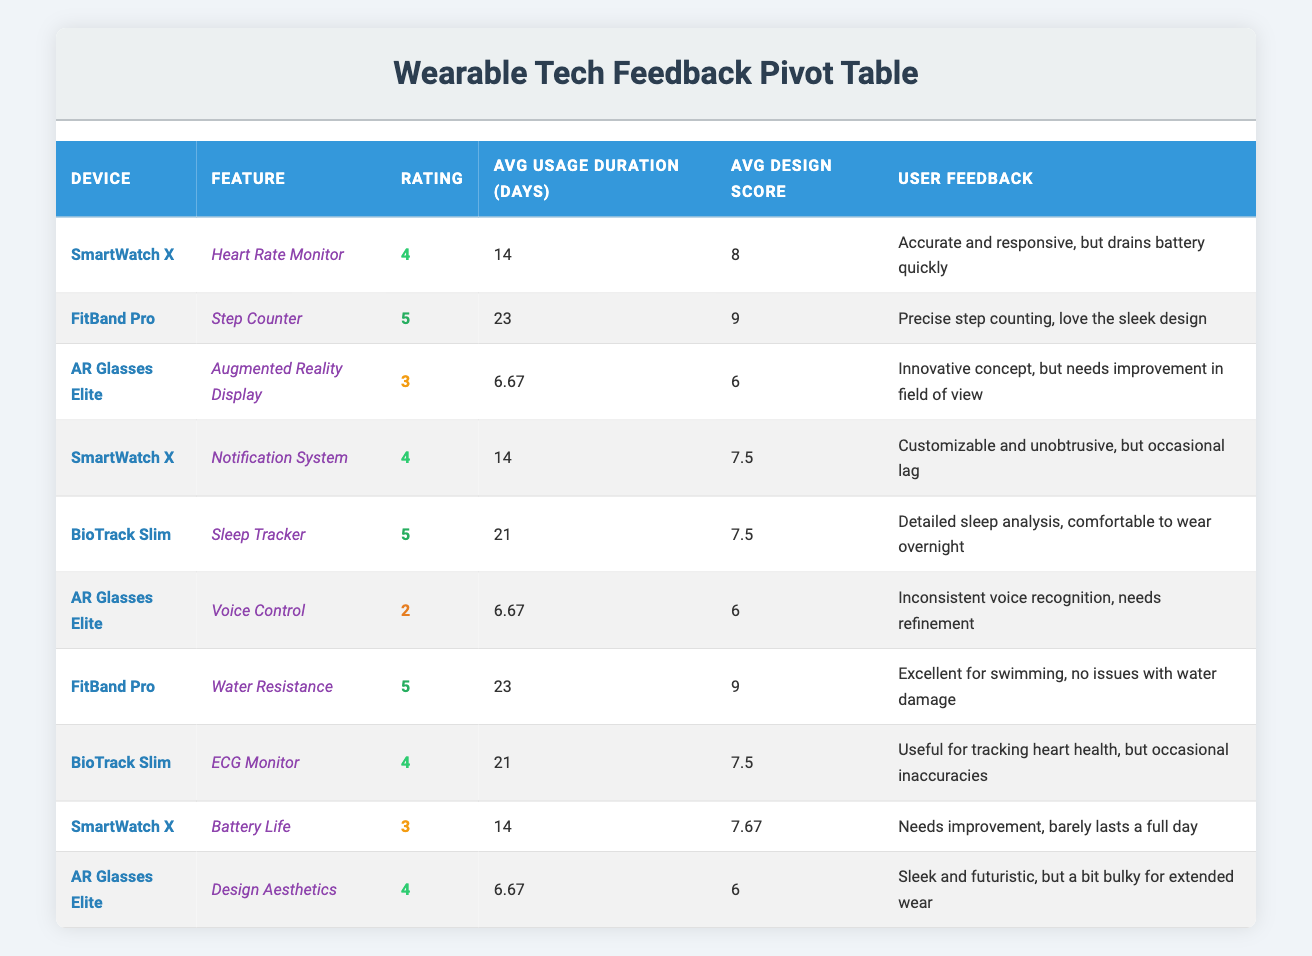What is the highest rating among all devices? By looking through the "Rating" column, we see that "FitBand Pro" has the highest rating of 5.
Answer: 5 What is the average design score across all the devices? Adding all the design scores (8 + 9 + 6 + 7 + 8 + 5 + 9 + 7.5 + 7.67 + 6) gives us a total of 78.17. There are 10 devices, so 78.17 divided by 10 equals 7.82.
Answer: 7.82 Did "Lisa Patel" give a high rating to the "AR Glasses Elite"? "Lisa Patel" rated "AR Glasses Elite" with a rating of 2, which is not considered high.
Answer: No Which device has the longest average usage duration? The average usage durations are: "SmartWatch X" 14, "FitBand Pro" 23, "AR Glasses Elite" 6.67, "BioTrack Slim" 21. If we compare these, "FitBand Pro" has the longest average usage duration of 23 days.
Answer: FitBand Pro What is the total number of users who rated "SmartWatch X"? "SmartWatch X" appears three times in the table; therefore, the total number of users who rated it is 3.
Answer: 3 What percentage of users gave a rating of 5 for "BioTrack Slim"? "BioTrack Slim" has 2 entries: one rated 5 and another rated 4. To find the percentage, divide the number of 5 ratings (1) by the total number of ratings (2) and multiply by 100, yielding 50% for "BioTrack Slim."
Answer: 50% Which device features complaints about battery lifespan? "SmartWatch X" includes feedback about battery life, stating it "Needs improvement, barely lasts a full day," indicating issues with battery lifespan.
Answer: SmartWatch X How many features did "FitBand Pro" receive ratings for, and what were they? "FitBand Pro" is rated for two features: "Step Counter" (5 rating) and "Water Resistance" (5 rating), indicating that it has received ratings for two features.
Answer: 2 features: Step Counter, Water Resistance What is the feedback from "Michael Rodriguez" about the "AR Glasses Elite"? According to the feedback provided by "Michael Rodriguez," he stated, "Innovative concept, but needs improvement in field of view," which indicates some dissatisfaction with the device.
Answer: Needs improvement in field of view 